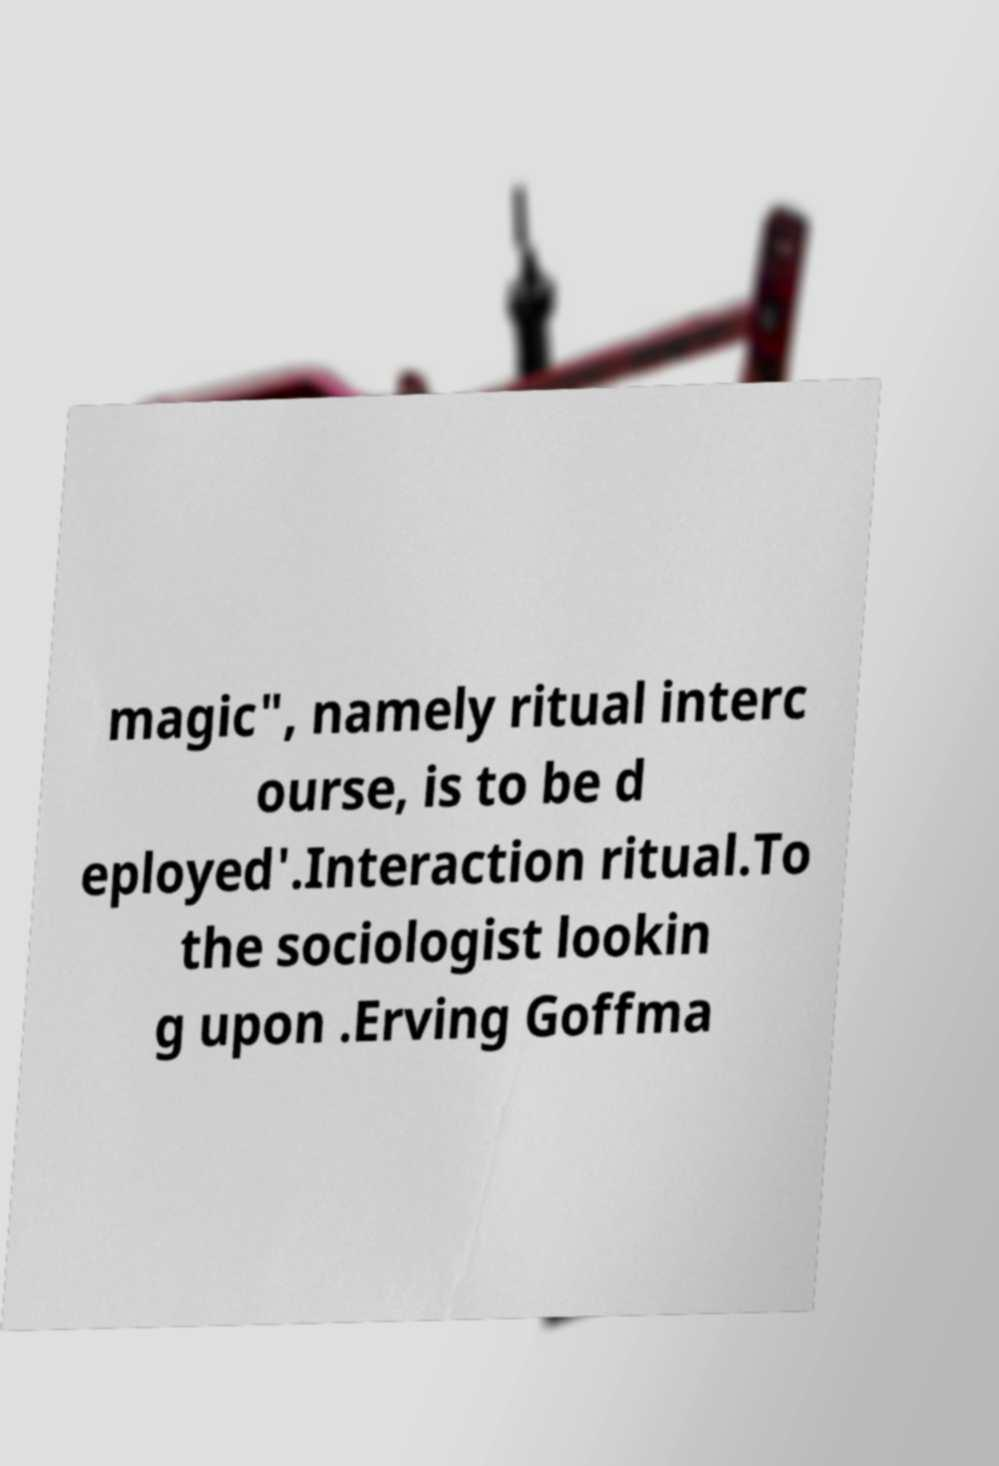For documentation purposes, I need the text within this image transcribed. Could you provide that? magic", namely ritual interc ourse, is to be d eployed'.Interaction ritual.To the sociologist lookin g upon .Erving Goffma 